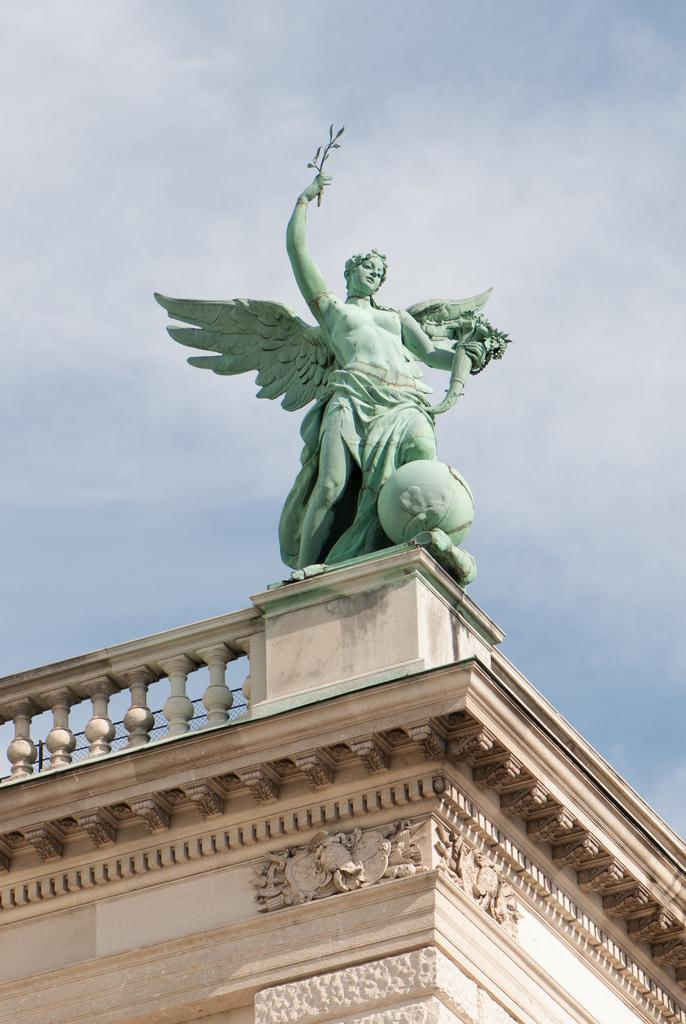What is the color of the statue in the image? The statue in the image is blue. Where is the statue located in relation to the building? The statue is above a building. What type of fencing can be seen in the image? There is concrete fencing in the image. What can be seen in the background of the image? The sky and clouds are visible in the background of the image. How many books are stacked on the statue in the image? There are no books present in the image; it features a blue color statue above a building with concrete fencing and a sky background with clouds. 